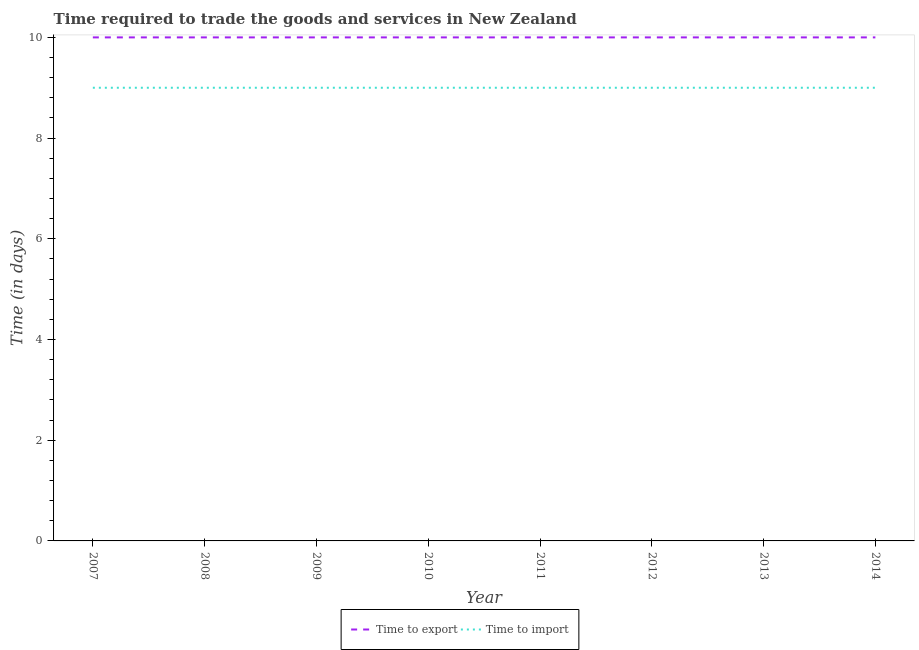How many different coloured lines are there?
Your response must be concise. 2. Does the line corresponding to time to import intersect with the line corresponding to time to export?
Offer a very short reply. No. Is the number of lines equal to the number of legend labels?
Provide a short and direct response. Yes. What is the time to import in 2009?
Give a very brief answer. 9. Across all years, what is the maximum time to import?
Give a very brief answer. 9. Across all years, what is the minimum time to import?
Give a very brief answer. 9. What is the total time to export in the graph?
Your response must be concise. 80. What is the difference between the time to export in 2007 and that in 2012?
Ensure brevity in your answer.  0. What is the difference between the time to import in 2010 and the time to export in 2011?
Keep it short and to the point. -1. In the year 2007, what is the difference between the time to import and time to export?
Ensure brevity in your answer.  -1. What is the ratio of the time to import in 2008 to that in 2009?
Ensure brevity in your answer.  1. What is the difference between the highest and the second highest time to import?
Offer a very short reply. 0. What is the difference between the highest and the lowest time to export?
Your answer should be compact. 0. Is the sum of the time to import in 2007 and 2010 greater than the maximum time to export across all years?
Keep it short and to the point. Yes. How many years are there in the graph?
Make the answer very short. 8. What is the difference between two consecutive major ticks on the Y-axis?
Your answer should be compact. 2. Does the graph contain any zero values?
Give a very brief answer. No. Does the graph contain grids?
Your answer should be compact. No. Where does the legend appear in the graph?
Offer a very short reply. Bottom center. What is the title of the graph?
Offer a very short reply. Time required to trade the goods and services in New Zealand. What is the label or title of the Y-axis?
Provide a succinct answer. Time (in days). What is the Time (in days) of Time to export in 2007?
Provide a short and direct response. 10. What is the Time (in days) of Time to export in 2008?
Offer a very short reply. 10. What is the Time (in days) of Time to import in 2008?
Your answer should be very brief. 9. What is the Time (in days) of Time to import in 2009?
Offer a very short reply. 9. What is the Time (in days) in Time to export in 2011?
Your answer should be compact. 10. What is the Time (in days) of Time to export in 2012?
Keep it short and to the point. 10. What is the Time (in days) in Time to import in 2012?
Keep it short and to the point. 9. What is the Time (in days) of Time to import in 2013?
Make the answer very short. 9. What is the Time (in days) of Time to export in 2014?
Make the answer very short. 10. Across all years, what is the maximum Time (in days) in Time to export?
Give a very brief answer. 10. Across all years, what is the minimum Time (in days) in Time to export?
Make the answer very short. 10. Across all years, what is the minimum Time (in days) of Time to import?
Keep it short and to the point. 9. What is the total Time (in days) in Time to export in the graph?
Your response must be concise. 80. What is the difference between the Time (in days) in Time to export in 2007 and that in 2008?
Make the answer very short. 0. What is the difference between the Time (in days) of Time to import in 2007 and that in 2008?
Ensure brevity in your answer.  0. What is the difference between the Time (in days) in Time to export in 2007 and that in 2009?
Ensure brevity in your answer.  0. What is the difference between the Time (in days) of Time to import in 2007 and that in 2009?
Keep it short and to the point. 0. What is the difference between the Time (in days) in Time to import in 2007 and that in 2010?
Your answer should be compact. 0. What is the difference between the Time (in days) of Time to import in 2007 and that in 2011?
Your answer should be very brief. 0. What is the difference between the Time (in days) in Time to export in 2007 and that in 2012?
Offer a terse response. 0. What is the difference between the Time (in days) of Time to import in 2007 and that in 2012?
Your answer should be compact. 0. What is the difference between the Time (in days) of Time to export in 2007 and that in 2013?
Offer a terse response. 0. What is the difference between the Time (in days) in Time to export in 2007 and that in 2014?
Offer a terse response. 0. What is the difference between the Time (in days) in Time to import in 2007 and that in 2014?
Keep it short and to the point. 0. What is the difference between the Time (in days) of Time to export in 2008 and that in 2009?
Provide a short and direct response. 0. What is the difference between the Time (in days) in Time to import in 2008 and that in 2009?
Your answer should be very brief. 0. What is the difference between the Time (in days) of Time to import in 2008 and that in 2010?
Offer a terse response. 0. What is the difference between the Time (in days) in Time to export in 2008 and that in 2012?
Ensure brevity in your answer.  0. What is the difference between the Time (in days) in Time to export in 2008 and that in 2014?
Give a very brief answer. 0. What is the difference between the Time (in days) in Time to import in 2009 and that in 2010?
Provide a succinct answer. 0. What is the difference between the Time (in days) in Time to export in 2009 and that in 2011?
Make the answer very short. 0. What is the difference between the Time (in days) of Time to import in 2009 and that in 2013?
Your answer should be compact. 0. What is the difference between the Time (in days) in Time to export in 2009 and that in 2014?
Your answer should be very brief. 0. What is the difference between the Time (in days) of Time to import in 2009 and that in 2014?
Your answer should be very brief. 0. What is the difference between the Time (in days) in Time to import in 2010 and that in 2011?
Provide a succinct answer. 0. What is the difference between the Time (in days) in Time to import in 2010 and that in 2012?
Offer a very short reply. 0. What is the difference between the Time (in days) in Time to import in 2010 and that in 2013?
Your answer should be compact. 0. What is the difference between the Time (in days) of Time to export in 2010 and that in 2014?
Provide a succinct answer. 0. What is the difference between the Time (in days) of Time to import in 2010 and that in 2014?
Make the answer very short. 0. What is the difference between the Time (in days) in Time to export in 2011 and that in 2012?
Your answer should be very brief. 0. What is the difference between the Time (in days) in Time to import in 2011 and that in 2013?
Offer a terse response. 0. What is the difference between the Time (in days) of Time to import in 2012 and that in 2013?
Provide a succinct answer. 0. What is the difference between the Time (in days) in Time to export in 2013 and that in 2014?
Your answer should be compact. 0. What is the difference between the Time (in days) of Time to import in 2013 and that in 2014?
Your answer should be compact. 0. What is the difference between the Time (in days) in Time to export in 2007 and the Time (in days) in Time to import in 2008?
Your answer should be compact. 1. What is the difference between the Time (in days) of Time to export in 2007 and the Time (in days) of Time to import in 2009?
Your response must be concise. 1. What is the difference between the Time (in days) in Time to export in 2007 and the Time (in days) in Time to import in 2010?
Your answer should be very brief. 1. What is the difference between the Time (in days) in Time to export in 2007 and the Time (in days) in Time to import in 2011?
Your answer should be compact. 1. What is the difference between the Time (in days) of Time to export in 2007 and the Time (in days) of Time to import in 2014?
Your response must be concise. 1. What is the difference between the Time (in days) of Time to export in 2008 and the Time (in days) of Time to import in 2010?
Offer a very short reply. 1. What is the difference between the Time (in days) in Time to export in 2008 and the Time (in days) in Time to import in 2011?
Provide a succinct answer. 1. What is the difference between the Time (in days) in Time to export in 2008 and the Time (in days) in Time to import in 2012?
Your response must be concise. 1. What is the difference between the Time (in days) in Time to export in 2008 and the Time (in days) in Time to import in 2014?
Offer a very short reply. 1. What is the difference between the Time (in days) of Time to export in 2009 and the Time (in days) of Time to import in 2010?
Offer a terse response. 1. What is the difference between the Time (in days) in Time to export in 2009 and the Time (in days) in Time to import in 2011?
Offer a terse response. 1. What is the difference between the Time (in days) in Time to export in 2009 and the Time (in days) in Time to import in 2012?
Ensure brevity in your answer.  1. What is the difference between the Time (in days) in Time to export in 2009 and the Time (in days) in Time to import in 2014?
Give a very brief answer. 1. What is the difference between the Time (in days) of Time to export in 2010 and the Time (in days) of Time to import in 2011?
Your answer should be very brief. 1. What is the difference between the Time (in days) of Time to export in 2010 and the Time (in days) of Time to import in 2014?
Give a very brief answer. 1. What is the difference between the Time (in days) in Time to export in 2011 and the Time (in days) in Time to import in 2013?
Your answer should be very brief. 1. What is the difference between the Time (in days) in Time to export in 2011 and the Time (in days) in Time to import in 2014?
Your answer should be very brief. 1. What is the average Time (in days) in Time to export per year?
Your answer should be very brief. 10. What is the average Time (in days) of Time to import per year?
Provide a succinct answer. 9. In the year 2007, what is the difference between the Time (in days) in Time to export and Time (in days) in Time to import?
Offer a very short reply. 1. In the year 2008, what is the difference between the Time (in days) in Time to export and Time (in days) in Time to import?
Offer a very short reply. 1. In the year 2009, what is the difference between the Time (in days) of Time to export and Time (in days) of Time to import?
Your answer should be compact. 1. In the year 2010, what is the difference between the Time (in days) of Time to export and Time (in days) of Time to import?
Offer a very short reply. 1. In the year 2012, what is the difference between the Time (in days) in Time to export and Time (in days) in Time to import?
Provide a succinct answer. 1. In the year 2013, what is the difference between the Time (in days) of Time to export and Time (in days) of Time to import?
Your response must be concise. 1. In the year 2014, what is the difference between the Time (in days) of Time to export and Time (in days) of Time to import?
Make the answer very short. 1. What is the ratio of the Time (in days) in Time to export in 2007 to that in 2008?
Offer a terse response. 1. What is the ratio of the Time (in days) in Time to export in 2007 to that in 2009?
Provide a succinct answer. 1. What is the ratio of the Time (in days) of Time to import in 2007 to that in 2010?
Give a very brief answer. 1. What is the ratio of the Time (in days) of Time to export in 2007 to that in 2011?
Your answer should be very brief. 1. What is the ratio of the Time (in days) in Time to export in 2007 to that in 2012?
Give a very brief answer. 1. What is the ratio of the Time (in days) of Time to import in 2007 to that in 2012?
Provide a short and direct response. 1. What is the ratio of the Time (in days) of Time to export in 2007 to that in 2013?
Keep it short and to the point. 1. What is the ratio of the Time (in days) in Time to export in 2007 to that in 2014?
Make the answer very short. 1. What is the ratio of the Time (in days) of Time to export in 2008 to that in 2009?
Make the answer very short. 1. What is the ratio of the Time (in days) of Time to import in 2008 to that in 2009?
Provide a succinct answer. 1. What is the ratio of the Time (in days) in Time to export in 2008 to that in 2011?
Provide a short and direct response. 1. What is the ratio of the Time (in days) in Time to import in 2008 to that in 2011?
Ensure brevity in your answer.  1. What is the ratio of the Time (in days) of Time to import in 2008 to that in 2012?
Ensure brevity in your answer.  1. What is the ratio of the Time (in days) in Time to import in 2008 to that in 2013?
Provide a short and direct response. 1. What is the ratio of the Time (in days) in Time to export in 2009 to that in 2010?
Give a very brief answer. 1. What is the ratio of the Time (in days) of Time to import in 2009 to that in 2011?
Your response must be concise. 1. What is the ratio of the Time (in days) of Time to import in 2009 to that in 2012?
Your answer should be very brief. 1. What is the ratio of the Time (in days) of Time to export in 2009 to that in 2013?
Offer a terse response. 1. What is the ratio of the Time (in days) in Time to import in 2009 to that in 2013?
Give a very brief answer. 1. What is the ratio of the Time (in days) of Time to export in 2010 to that in 2011?
Your answer should be compact. 1. What is the ratio of the Time (in days) in Time to import in 2010 to that in 2011?
Keep it short and to the point. 1. What is the ratio of the Time (in days) in Time to import in 2010 to that in 2013?
Offer a terse response. 1. What is the ratio of the Time (in days) of Time to export in 2010 to that in 2014?
Keep it short and to the point. 1. What is the ratio of the Time (in days) in Time to import in 2011 to that in 2012?
Your answer should be very brief. 1. What is the ratio of the Time (in days) in Time to export in 2011 to that in 2013?
Provide a succinct answer. 1. What is the ratio of the Time (in days) of Time to export in 2011 to that in 2014?
Keep it short and to the point. 1. What is the ratio of the Time (in days) of Time to export in 2012 to that in 2013?
Ensure brevity in your answer.  1. What is the ratio of the Time (in days) in Time to import in 2012 to that in 2014?
Your answer should be very brief. 1. What is the ratio of the Time (in days) of Time to export in 2013 to that in 2014?
Provide a succinct answer. 1. What is the ratio of the Time (in days) in Time to import in 2013 to that in 2014?
Make the answer very short. 1. What is the difference between the highest and the second highest Time (in days) in Time to import?
Give a very brief answer. 0. 